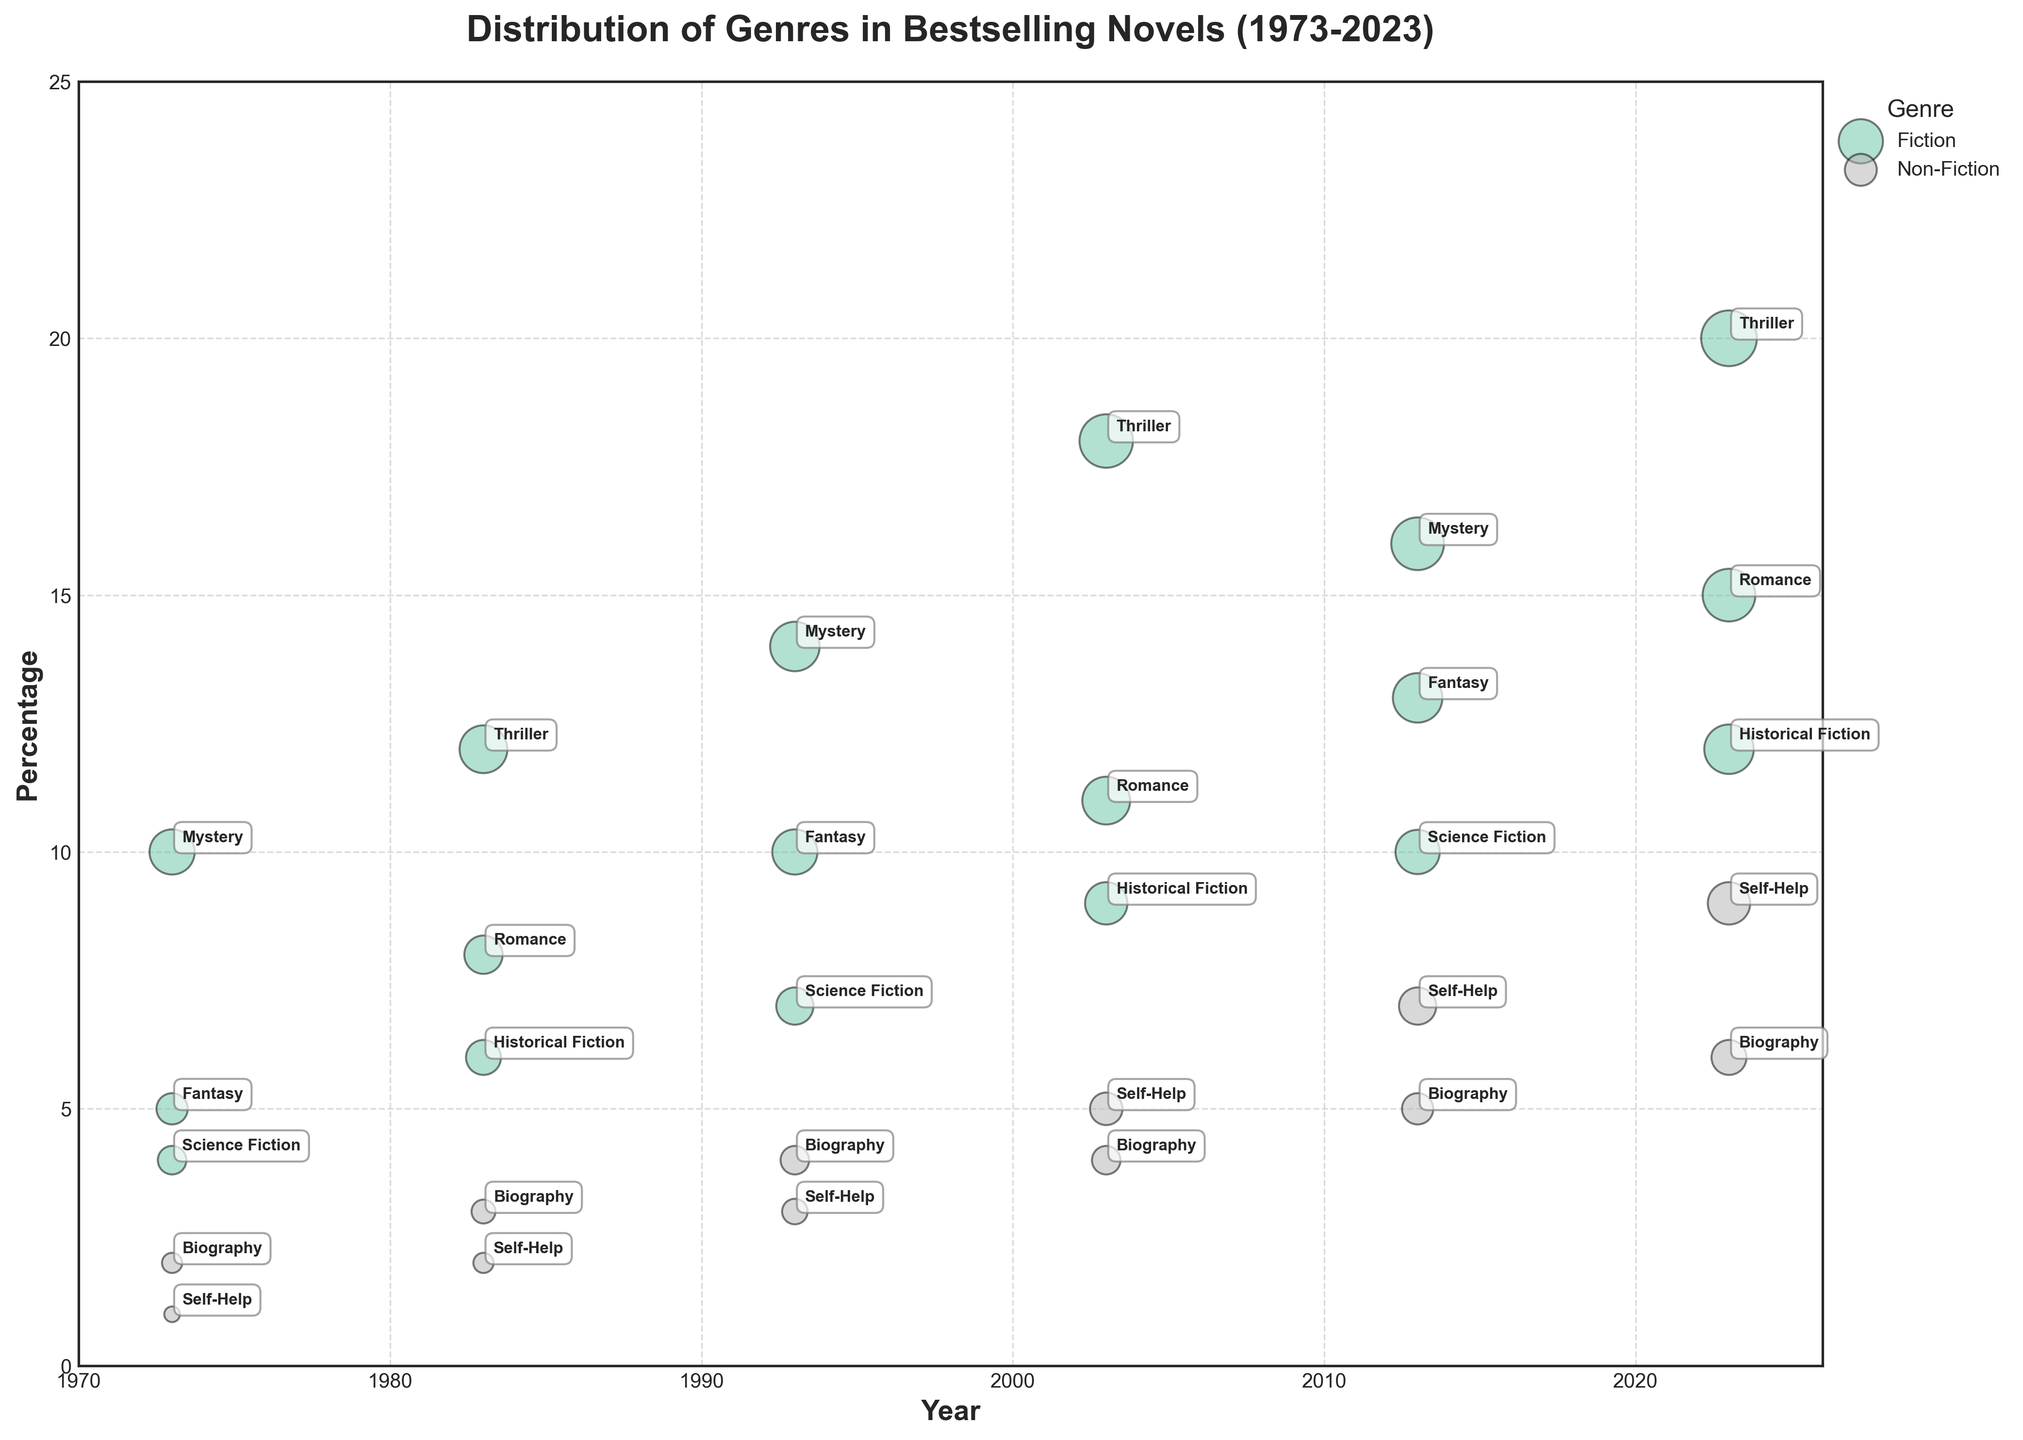What is the title of the figure? The title is displayed at the top center of the figure. It is "Distribution of Genres in Bestselling Novels (1973-2023)"
Answer: Distribution of Genres in Bestselling Novels (1973-2023) What are the labels on the x-axis and y-axis? The x-axis and y-axis labels are placed respectively at the bottom and the left side of the figure. The x-axis label is "Year," and the y-axis label is "Percentage."
Answer: Year; Percentage Which genre has the largest percentage in 2023? Locate the year 2023 on the x-axis, then identify the largest bubble (by size and percentage). The largest bubble corresponds to the "Fiction, Thriller" sub-genre, with the highest percentage.
Answer: Fiction, Thriller How many sub-genres are represented in the year 1983? Locate the year 1983 on the x-axis and count the number of bubbles present. Each bubble signifies a different sub-genre. There are 5 sub-genres: Historical Fiction, Romance, Thriller, Biography, and Self-Help.
Answer: 5 Which non-fiction sub-genre shows a consistent increase in percentage over the decades? For the non-fiction sub-genres, track their percentages across the years. The "Self-Help" sub-genre shows an increase from 1973 to 2023 (1%, 2%, 3%, 5%, 7%, and 9% respectively).
Answer: Self-Help How has the percentage of Fiction, Fantasy changed from 1973 to 2023? Locate the "Fiction, Fantasy" bubbles for the years (1973, 1993, 2013, 2023) and assess how the percentage has increased.  It changed from 5% in 1973 to 10% in 1993, 13% in 2013, and 15% in 2023, indicating an overall increase.
Answer: Increased Which year shows the highest variety in sub-genres for Fiction? Count the unique Fiction sub-genre bubbles for each year. 2023 represents the highest variety with Fiction sub-genres: Historical Fiction, Romance, Thriller, Science Fiction, Fantasy, and Mystery (6 sub-genres).
Answer: 2023 What is the total percentage of Fiction sub-genres in 1993? Sum up the percentages of all Fiction sub-genres in 1993. The percentages are Science Fiction (7), Fantasy (10), Mystery (14), making a total of 7 + 10 + 14 = 31%.
Answer: 31% Which sub-genre had the most significant bubble size in 2003? Identify the largest bubble in 2003 by looking at the BubbleSize. The most significant bubble size corresponds to the Thriller sub-genre with a BubbleSize of 35.
Answer: Thriller 